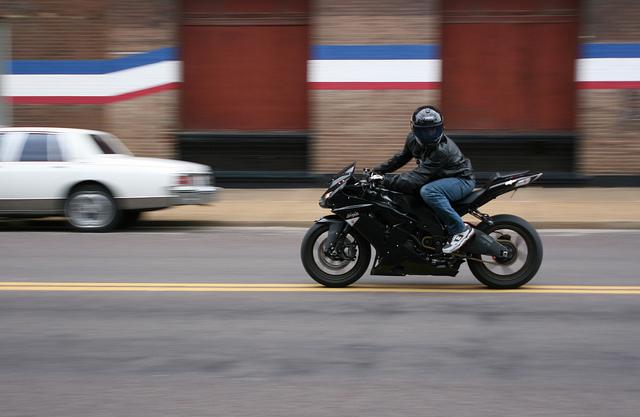Which former country had a flag which looks similar to these banners? yugoslavia 